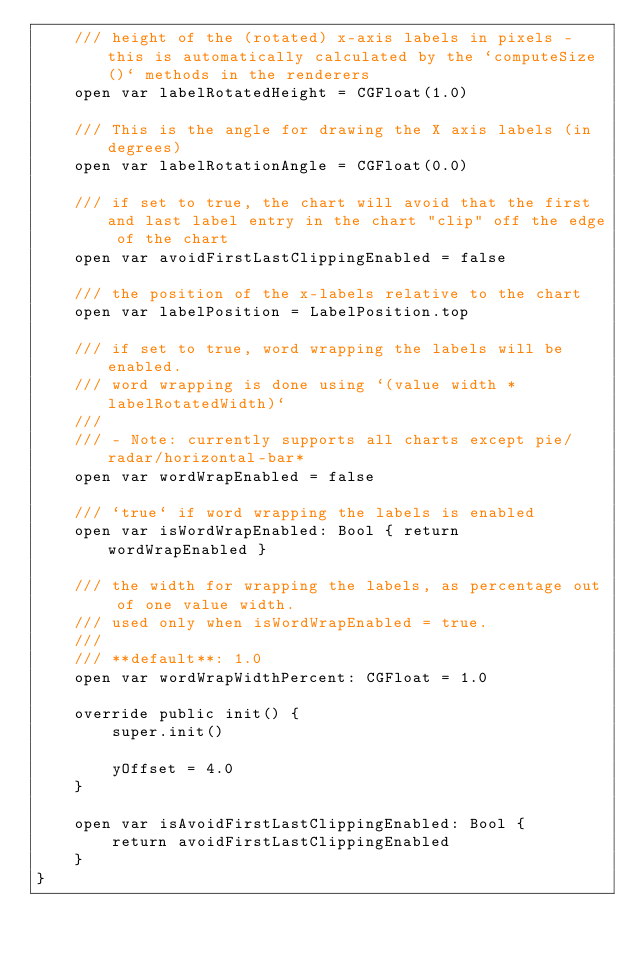<code> <loc_0><loc_0><loc_500><loc_500><_Swift_>    /// height of the (rotated) x-axis labels in pixels - this is automatically calculated by the `computeSize()` methods in the renderers
    open var labelRotatedHeight = CGFloat(1.0)

    /// This is the angle for drawing the X axis labels (in degrees)
    open var labelRotationAngle = CGFloat(0.0)

    /// if set to true, the chart will avoid that the first and last label entry in the chart "clip" off the edge of the chart
    open var avoidFirstLastClippingEnabled = false

    /// the position of the x-labels relative to the chart
    open var labelPosition = LabelPosition.top

    /// if set to true, word wrapping the labels will be enabled.
    /// word wrapping is done using `(value width * labelRotatedWidth)`
    ///
    /// - Note: currently supports all charts except pie/radar/horizontal-bar*
    open var wordWrapEnabled = false

    /// `true` if word wrapping the labels is enabled
    open var isWordWrapEnabled: Bool { return wordWrapEnabled }

    /// the width for wrapping the labels, as percentage out of one value width.
    /// used only when isWordWrapEnabled = true.
    ///
    /// **default**: 1.0
    open var wordWrapWidthPercent: CGFloat = 1.0

    override public init() {
        super.init()

        yOffset = 4.0
    }

    open var isAvoidFirstLastClippingEnabled: Bool {
        return avoidFirstLastClippingEnabled
    }
}
</code> 